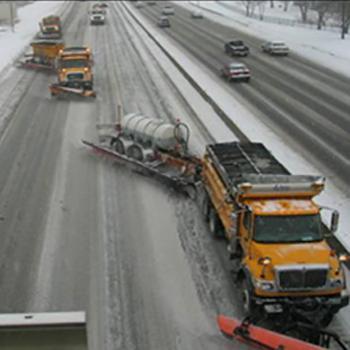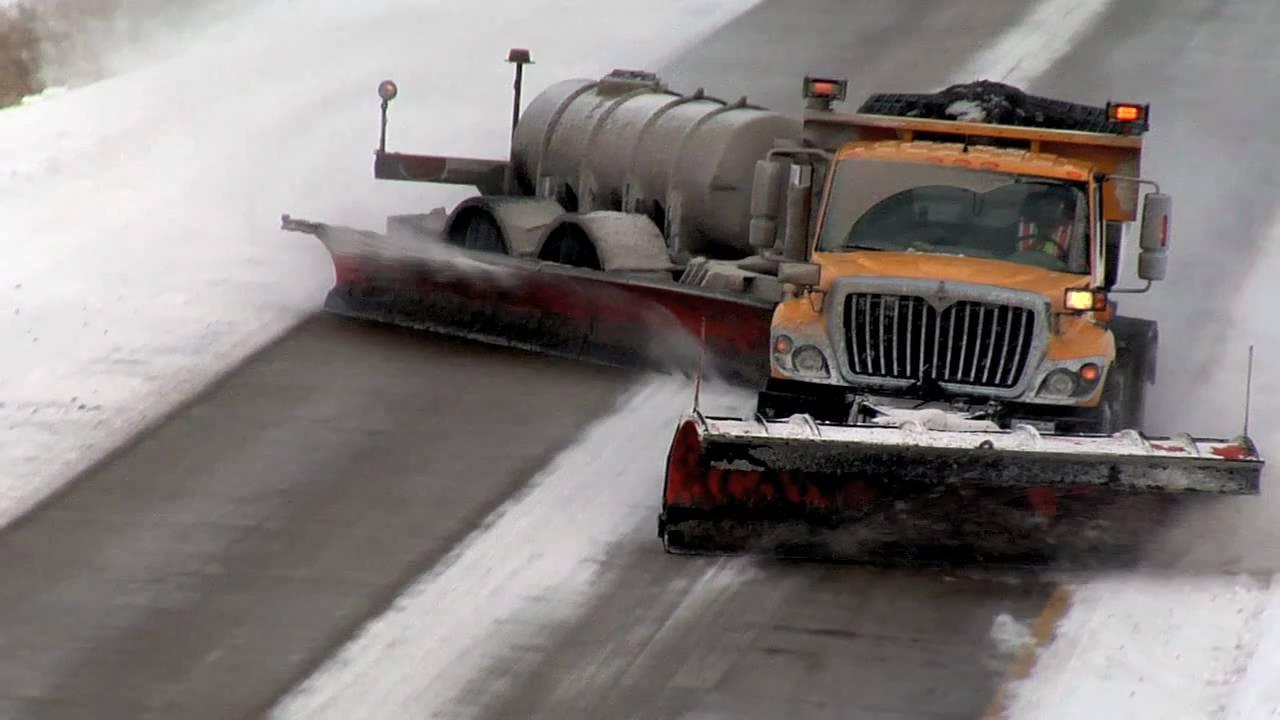The first image is the image on the left, the second image is the image on the right. Assess this claim about the two images: "Both images show at least one camera-facing tow plow truck with a yellow cab, clearing a snowy road.". Correct or not? Answer yes or no. Yes. 